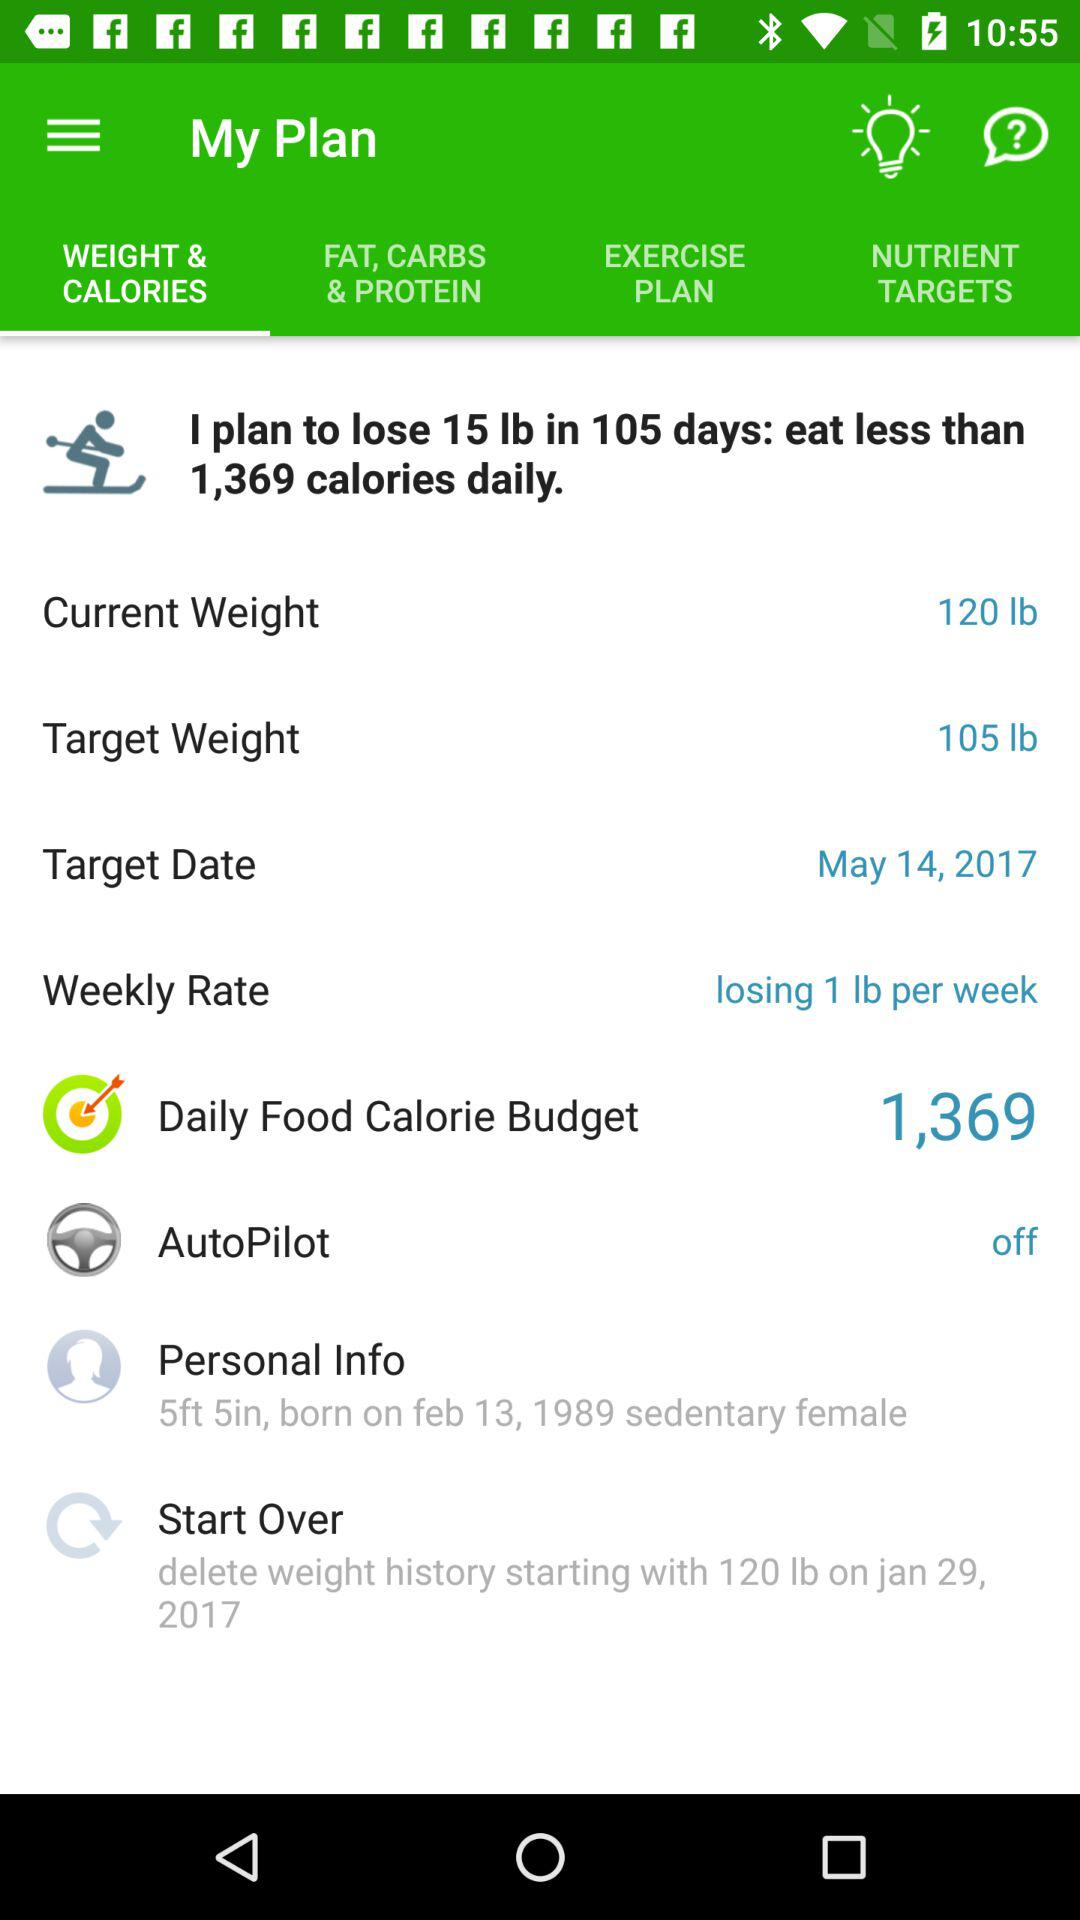What is the date of birth of the person? The date of birth of the person is February 13, 1989. 